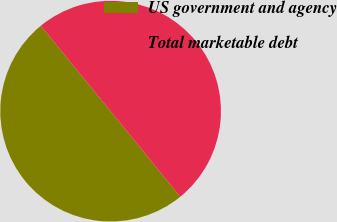<chart> <loc_0><loc_0><loc_500><loc_500><pie_chart><fcel>US government and agency<fcel>Total marketable debt<nl><fcel>49.97%<fcel>50.03%<nl></chart> 